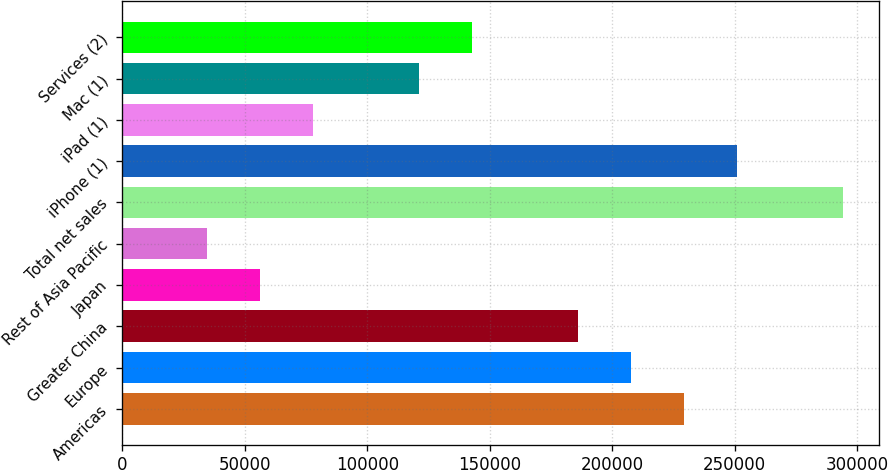Convert chart to OTSL. <chart><loc_0><loc_0><loc_500><loc_500><bar_chart><fcel>Americas<fcel>Europe<fcel>Greater China<fcel>Japan<fcel>Rest of Asia Pacific<fcel>Total net sales<fcel>iPhone (1)<fcel>iPad (1)<fcel>Mac (1)<fcel>Services (2)<nl><fcel>229234<fcel>207597<fcel>185960<fcel>56137.2<fcel>34500.1<fcel>294145<fcel>250871<fcel>77774.3<fcel>121048<fcel>142686<nl></chart> 